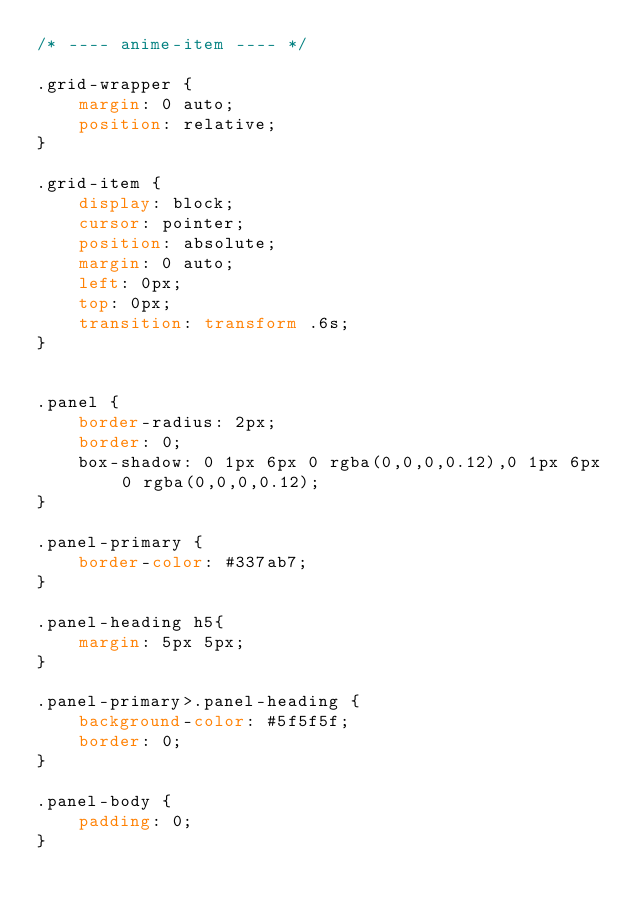Convert code to text. <code><loc_0><loc_0><loc_500><loc_500><_CSS_>/* ---- anime-item ---- */

.grid-wrapper {
    margin: 0 auto;
    position: relative;
}

.grid-item {
    display: block;
    cursor: pointer;
    position: absolute;
    margin: 0 auto;
    left: 0px;
    top: 0px;
    transition: transform .6s;
}


.panel {
    border-radius: 2px;
    border: 0;
    box-shadow: 0 1px 6px 0 rgba(0,0,0,0.12),0 1px 6px 0 rgba(0,0,0,0.12);
}

.panel-primary {
    border-color: #337ab7;
}

.panel-heading h5{
    margin: 5px 5px;
}

.panel-primary>.panel-heading {
    background-color: #5f5f5f;
    border: 0;
}

.panel-body {
    padding: 0;
}</code> 